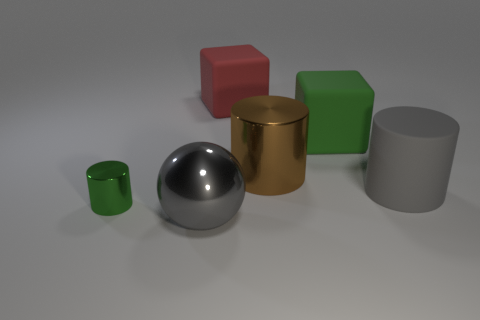Add 2 rubber cylinders. How many objects exist? 8 Subtract all blocks. How many objects are left? 4 Add 3 small cylinders. How many small cylinders exist? 4 Subtract 0 red cylinders. How many objects are left? 6 Subtract all brown matte blocks. Subtract all big things. How many objects are left? 1 Add 6 big shiny cylinders. How many big shiny cylinders are left? 7 